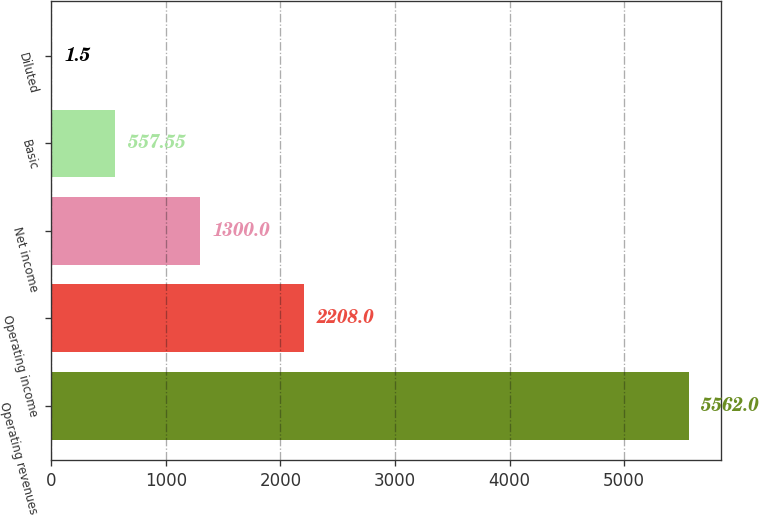Convert chart to OTSL. <chart><loc_0><loc_0><loc_500><loc_500><bar_chart><fcel>Operating revenues<fcel>Operating income<fcel>Net income<fcel>Basic<fcel>Diluted<nl><fcel>5562<fcel>2208<fcel>1300<fcel>557.55<fcel>1.5<nl></chart> 